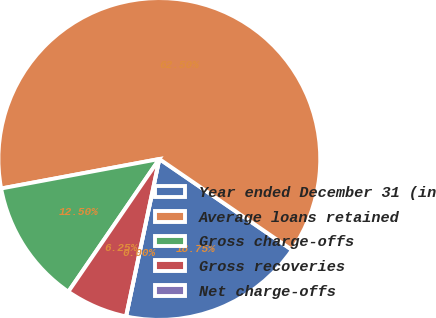Convert chart. <chart><loc_0><loc_0><loc_500><loc_500><pie_chart><fcel>Year ended December 31 (in<fcel>Average loans retained<fcel>Gross charge-offs<fcel>Gross recoveries<fcel>Net charge-offs<nl><fcel>18.75%<fcel>62.5%<fcel>12.5%<fcel>6.25%<fcel>0.0%<nl></chart> 